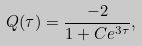Convert formula to latex. <formula><loc_0><loc_0><loc_500><loc_500>Q ( \tau ) = \frac { - 2 } { 1 + C e ^ { 3 \tau } } ,</formula> 